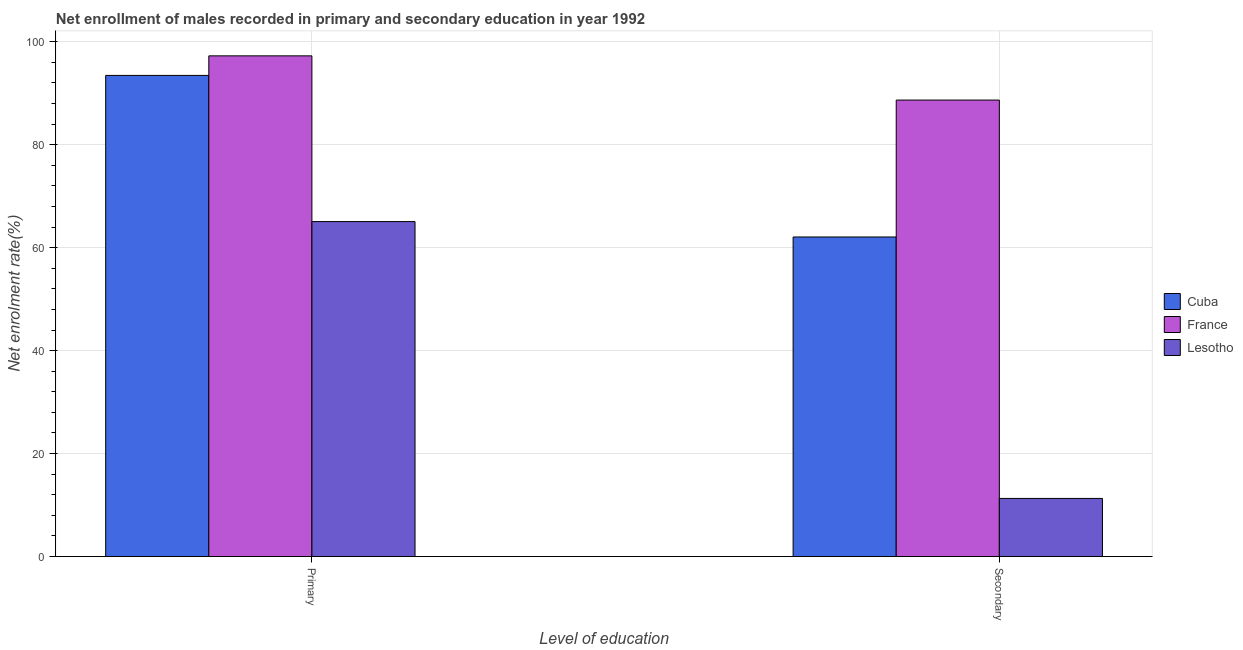How many different coloured bars are there?
Provide a short and direct response. 3. Are the number of bars on each tick of the X-axis equal?
Your response must be concise. Yes. What is the label of the 1st group of bars from the left?
Ensure brevity in your answer.  Primary. What is the enrollment rate in primary education in France?
Offer a terse response. 97.25. Across all countries, what is the maximum enrollment rate in secondary education?
Your response must be concise. 88.67. Across all countries, what is the minimum enrollment rate in primary education?
Offer a very short reply. 65.06. In which country was the enrollment rate in primary education minimum?
Make the answer very short. Lesotho. What is the total enrollment rate in secondary education in the graph?
Your answer should be very brief. 162.02. What is the difference between the enrollment rate in primary education in France and that in Cuba?
Ensure brevity in your answer.  3.8. What is the difference between the enrollment rate in primary education in Cuba and the enrollment rate in secondary education in France?
Offer a terse response. 4.79. What is the average enrollment rate in primary education per country?
Offer a very short reply. 85.25. What is the difference between the enrollment rate in primary education and enrollment rate in secondary education in France?
Offer a very short reply. 8.59. In how many countries, is the enrollment rate in secondary education greater than 76 %?
Your response must be concise. 1. What is the ratio of the enrollment rate in primary education in France to that in Lesotho?
Your response must be concise. 1.49. Is the enrollment rate in primary education in Lesotho less than that in Cuba?
Your answer should be very brief. Yes. In how many countries, is the enrollment rate in secondary education greater than the average enrollment rate in secondary education taken over all countries?
Your answer should be very brief. 2. What does the 2nd bar from the left in Primary represents?
Offer a terse response. France. How many countries are there in the graph?
Make the answer very short. 3. Where does the legend appear in the graph?
Provide a short and direct response. Center right. How many legend labels are there?
Offer a terse response. 3. What is the title of the graph?
Offer a terse response. Net enrollment of males recorded in primary and secondary education in year 1992. Does "Cabo Verde" appear as one of the legend labels in the graph?
Your response must be concise. No. What is the label or title of the X-axis?
Your answer should be very brief. Level of education. What is the label or title of the Y-axis?
Your response must be concise. Net enrolment rate(%). What is the Net enrolment rate(%) in Cuba in Primary?
Make the answer very short. 93.45. What is the Net enrolment rate(%) of France in Primary?
Provide a succinct answer. 97.25. What is the Net enrolment rate(%) of Lesotho in Primary?
Provide a short and direct response. 65.06. What is the Net enrolment rate(%) in Cuba in Secondary?
Offer a very short reply. 62.07. What is the Net enrolment rate(%) in France in Secondary?
Offer a very short reply. 88.67. What is the Net enrolment rate(%) of Lesotho in Secondary?
Your answer should be very brief. 11.28. Across all Level of education, what is the maximum Net enrolment rate(%) of Cuba?
Your answer should be very brief. 93.45. Across all Level of education, what is the maximum Net enrolment rate(%) in France?
Make the answer very short. 97.25. Across all Level of education, what is the maximum Net enrolment rate(%) of Lesotho?
Keep it short and to the point. 65.06. Across all Level of education, what is the minimum Net enrolment rate(%) in Cuba?
Provide a short and direct response. 62.07. Across all Level of education, what is the minimum Net enrolment rate(%) in France?
Ensure brevity in your answer.  88.67. Across all Level of education, what is the minimum Net enrolment rate(%) in Lesotho?
Your answer should be compact. 11.28. What is the total Net enrolment rate(%) of Cuba in the graph?
Provide a succinct answer. 155.52. What is the total Net enrolment rate(%) in France in the graph?
Your answer should be compact. 185.92. What is the total Net enrolment rate(%) in Lesotho in the graph?
Your answer should be very brief. 76.34. What is the difference between the Net enrolment rate(%) of Cuba in Primary and that in Secondary?
Provide a succinct answer. 31.38. What is the difference between the Net enrolment rate(%) of France in Primary and that in Secondary?
Make the answer very short. 8.59. What is the difference between the Net enrolment rate(%) in Lesotho in Primary and that in Secondary?
Your answer should be very brief. 53.78. What is the difference between the Net enrolment rate(%) of Cuba in Primary and the Net enrolment rate(%) of France in Secondary?
Ensure brevity in your answer.  4.79. What is the difference between the Net enrolment rate(%) in Cuba in Primary and the Net enrolment rate(%) in Lesotho in Secondary?
Give a very brief answer. 82.17. What is the difference between the Net enrolment rate(%) of France in Primary and the Net enrolment rate(%) of Lesotho in Secondary?
Ensure brevity in your answer.  85.97. What is the average Net enrolment rate(%) in Cuba per Level of education?
Make the answer very short. 77.76. What is the average Net enrolment rate(%) in France per Level of education?
Your response must be concise. 92.96. What is the average Net enrolment rate(%) in Lesotho per Level of education?
Provide a short and direct response. 38.17. What is the difference between the Net enrolment rate(%) in Cuba and Net enrolment rate(%) in Lesotho in Primary?
Make the answer very short. 28.39. What is the difference between the Net enrolment rate(%) in France and Net enrolment rate(%) in Lesotho in Primary?
Keep it short and to the point. 32.19. What is the difference between the Net enrolment rate(%) of Cuba and Net enrolment rate(%) of France in Secondary?
Offer a very short reply. -26.6. What is the difference between the Net enrolment rate(%) in Cuba and Net enrolment rate(%) in Lesotho in Secondary?
Provide a short and direct response. 50.79. What is the difference between the Net enrolment rate(%) in France and Net enrolment rate(%) in Lesotho in Secondary?
Your response must be concise. 77.38. What is the ratio of the Net enrolment rate(%) in Cuba in Primary to that in Secondary?
Offer a very short reply. 1.51. What is the ratio of the Net enrolment rate(%) in France in Primary to that in Secondary?
Ensure brevity in your answer.  1.1. What is the ratio of the Net enrolment rate(%) of Lesotho in Primary to that in Secondary?
Offer a terse response. 5.77. What is the difference between the highest and the second highest Net enrolment rate(%) in Cuba?
Keep it short and to the point. 31.38. What is the difference between the highest and the second highest Net enrolment rate(%) in France?
Keep it short and to the point. 8.59. What is the difference between the highest and the second highest Net enrolment rate(%) in Lesotho?
Your response must be concise. 53.78. What is the difference between the highest and the lowest Net enrolment rate(%) of Cuba?
Provide a succinct answer. 31.38. What is the difference between the highest and the lowest Net enrolment rate(%) in France?
Your answer should be very brief. 8.59. What is the difference between the highest and the lowest Net enrolment rate(%) in Lesotho?
Make the answer very short. 53.78. 